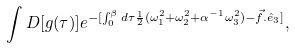<formula> <loc_0><loc_0><loc_500><loc_500>\int D [ g ( \tau ) ] e ^ { - [ \int _ { 0 } ^ { \beta } d \tau \frac { 1 } { 2 } ( \omega _ { 1 } ^ { 2 } + \omega _ { 2 } ^ { 2 } + \alpha ^ { - 1 } \omega _ { 3 } ^ { 2 } ) - { \vec { f } } . { \hat { e } _ { 3 } } ] } ,</formula> 